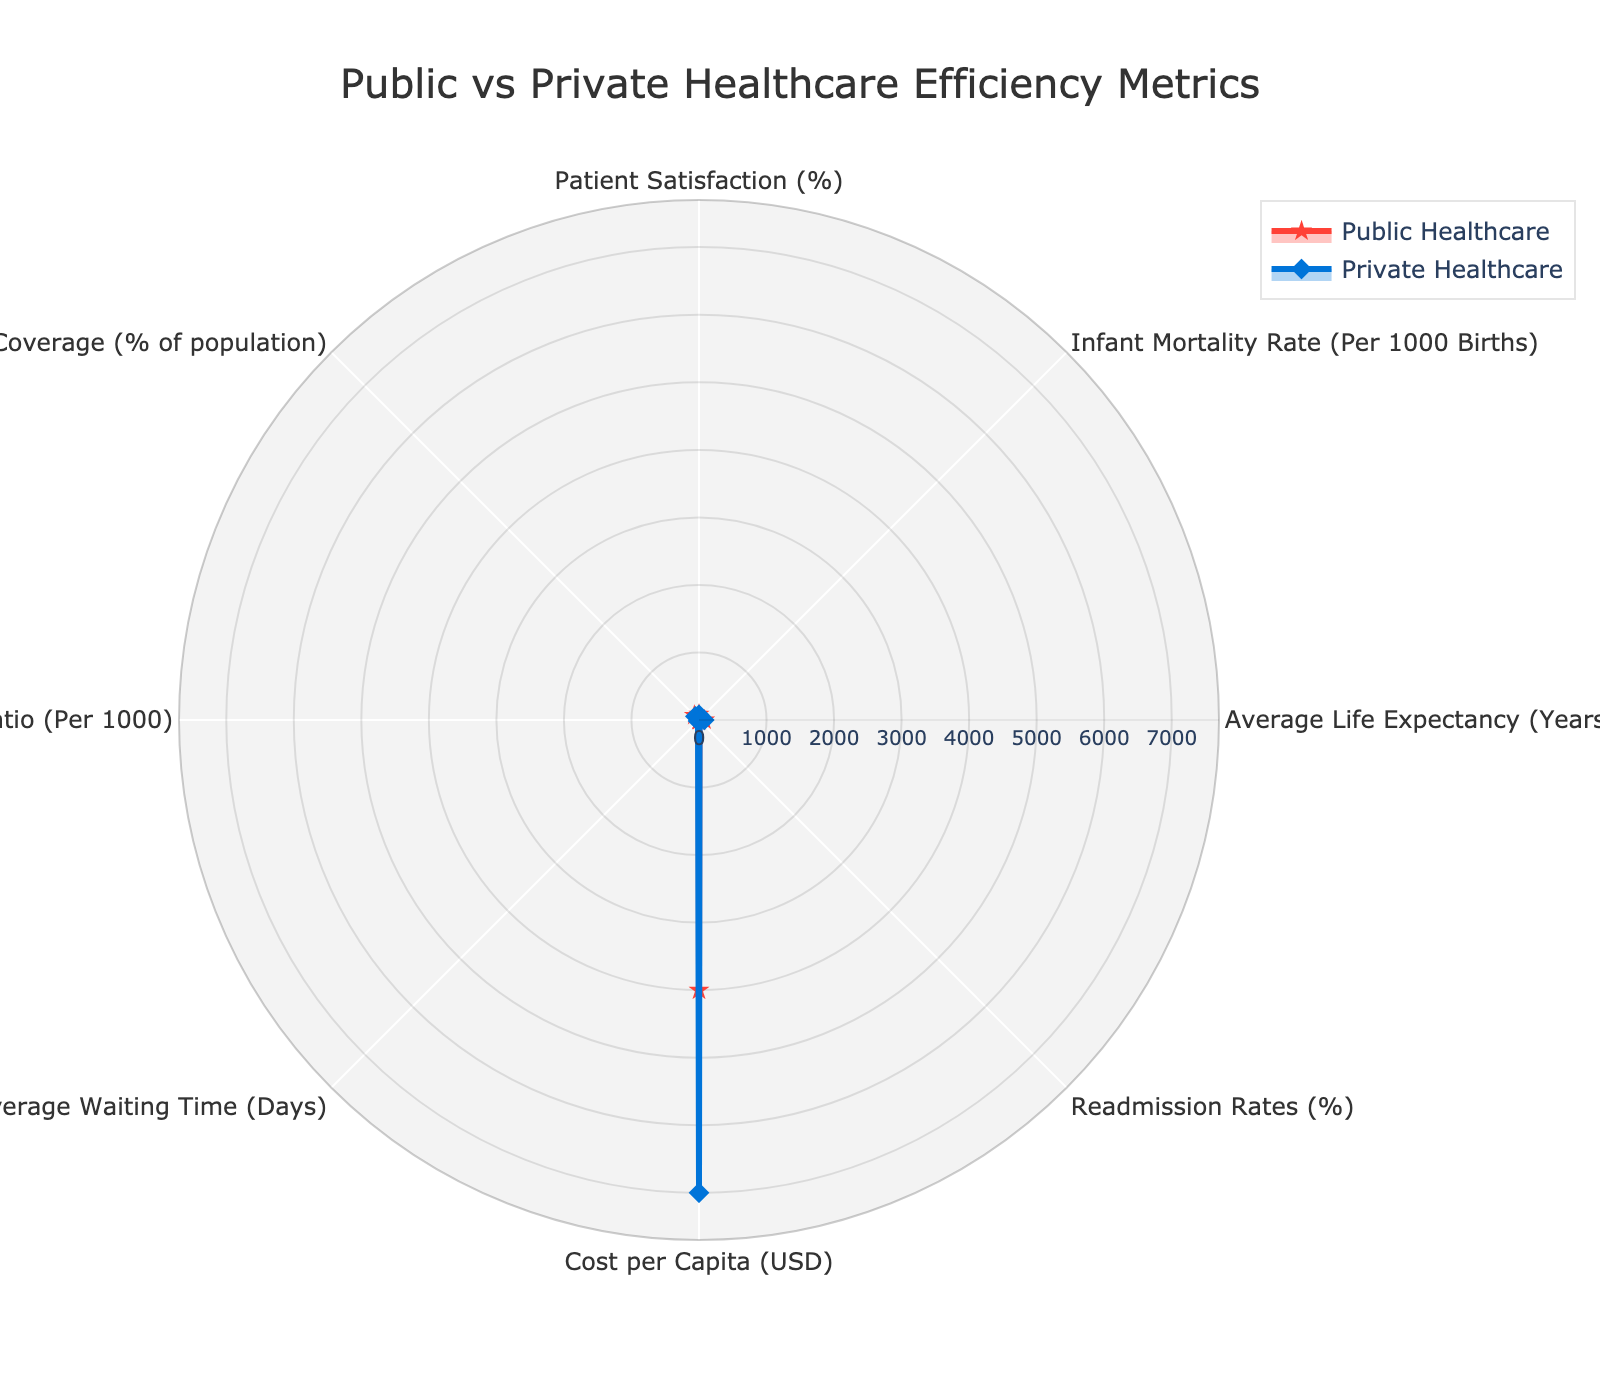what's the title of the figure? The title is located at the top of the figure and provides a summary of the information presented in the chart. It reads "Public vs Private Healthcare Efficiency Metrics".
Answer: Public vs Private Healthcare Efficiency Metrics how many data points are there for each category in the radar chart? Each category in the radar chart consists of two data points: one for Public Healthcare and one for Private Healthcare. Since there are eight categories, there are 16 data points in total.
Answer: 16 what's the highest value shown for Public Healthcare? The highest value shown for Public Healthcare can be found by looking at the radar chart and identifying the maximum point among Public Healthcare metrics. The highest value is for "Coverage (% of population)" at 97.
Answer: 97 which healthcare system has a better Doctor-to-Patient Ratio? By examining the values for "Doctor-to-Patient Ratio (Per 1000)" in the radar chart, Public Healthcare has a value of 3.5, while Private Healthcare has a value of 2.2. Public Healthcare has a higher Doctor-to-Patient Ratio.
Answer: Public Healthcare what is the percentage difference in Patient Satisfaction between Public Healthcare and Private Healthcare? To find the percentage difference, subtract the Patient Satisfaction of Private Healthcare (78%) from Public Healthcare (85%) and divide by Private Healthcare's value, then multiply by 100: ((85 - 78) / 78) * 100 = 8.97%.
Answer: 8.97% which category has the largest disparity between Public and Private Healthcare? The category with the largest disparity can be determined by evaluating the difference in values for Public and Private Healthcare in each category. "Coverage (% of population)" shows the largest disparity, with 97% for Public and 75% for Private, a difference of 22%.
Answer: Coverage (% of population) what is the average value for Infant Mortality Rate across both healthcare systems? The average value is calculated by adding the Infant Mortality Rate for both Public Healthcare (4) and Private Healthcare (6) and then dividing by 2: (4 + 6) / 2 = 5.
Answer: 5 which healthcare system has a higher Cost per Capita, and by how much? By comparing the Cost per Capita for Public Healthcare ($4000) and Private Healthcare ($7000), Private Healthcare is higher. The difference is $7000 - $4000 = $3000.
Answer: Private Healthcare by $3000 do both healthcare systems have better or equal values compared to the other in every category? By evaluating each category, it becomes evident that Public Healthcare has better or equal values in all categories except "Cost per Capita" and "Readmission Rates (%)," where Private Healthcare performs worse.
Answer: No which healthcare system has a shorter Average Waiting Time? By comparing the "Average Waiting Time (Days)" for each system, Public Healthcare has a value of 7 days, and Private Healthcare has 21 days. Public Healthcare has a shorter waiting time.
Answer: Public Healthcare 